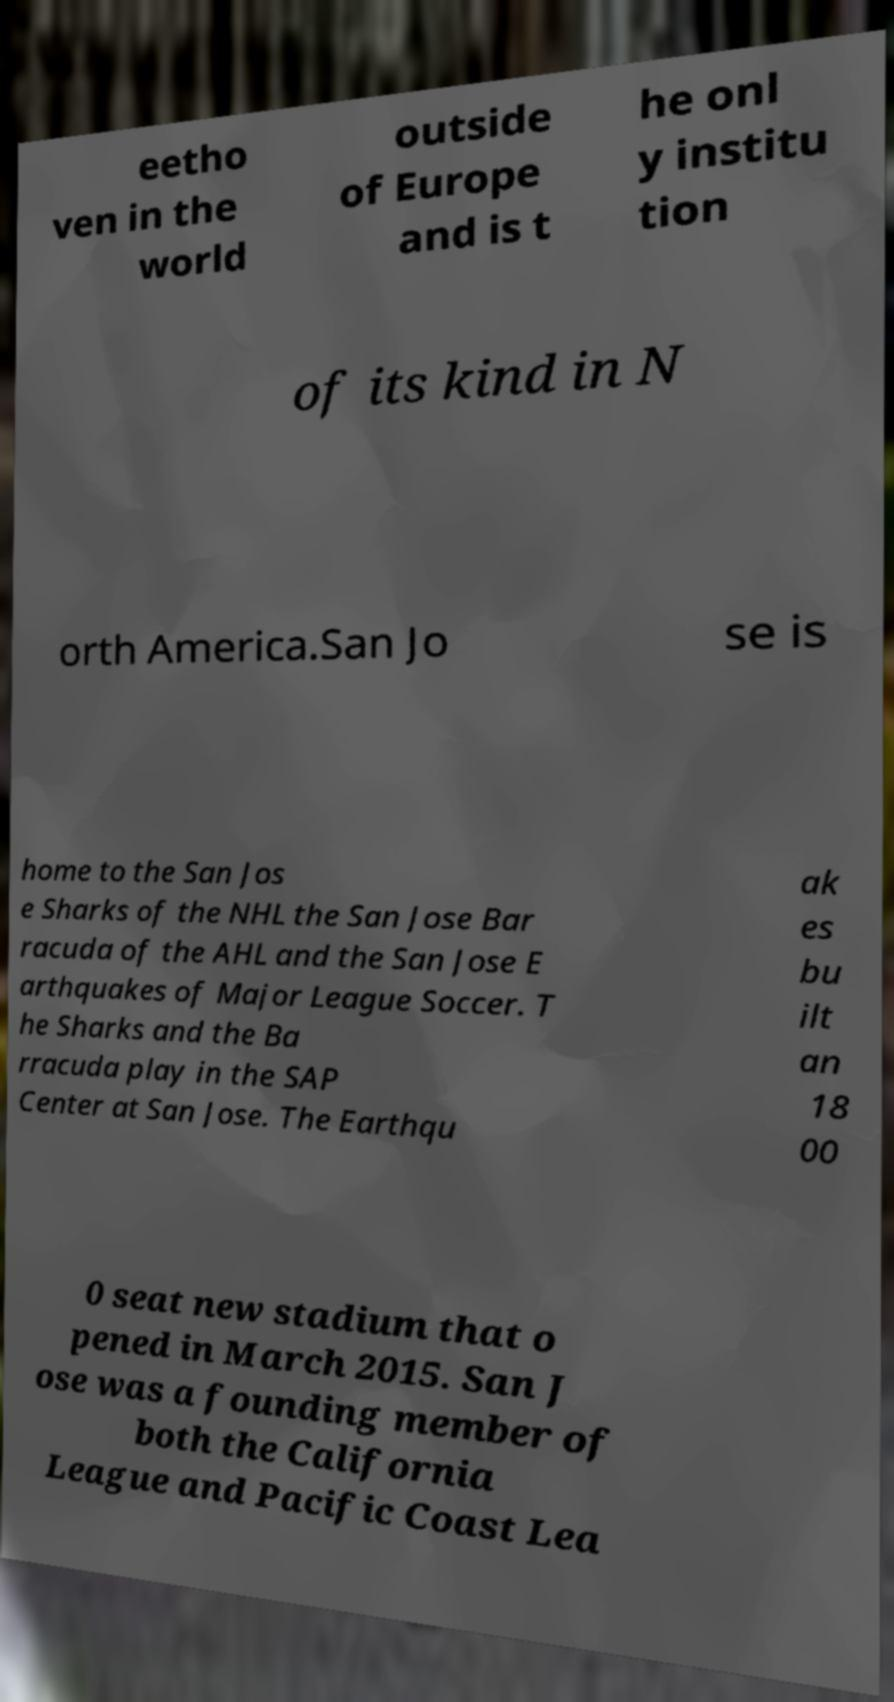Can you read and provide the text displayed in the image?This photo seems to have some interesting text. Can you extract and type it out for me? eetho ven in the world outside of Europe and is t he onl y institu tion of its kind in N orth America.San Jo se is home to the San Jos e Sharks of the NHL the San Jose Bar racuda of the AHL and the San Jose E arthquakes of Major League Soccer. T he Sharks and the Ba rracuda play in the SAP Center at San Jose. The Earthqu ak es bu ilt an 18 00 0 seat new stadium that o pened in March 2015. San J ose was a founding member of both the California League and Pacific Coast Lea 